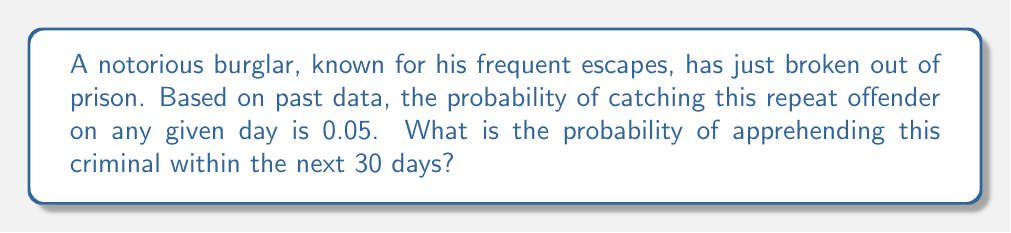Can you answer this question? Let's approach this step-by-step:

1) First, we need to calculate the probability of not catching the burglar on a single day:
   $P(\text{not caught on one day}) = 1 - 0.05 = 0.95$

2) Now, to not catch the burglar within 30 days, we need to not catch him every single day for 30 days. The probability of this is:
   $P(\text{not caught in 30 days}) = 0.95^{30}$

3) We can calculate this:
   $0.95^{30} \approx 0.2147$

4) The probability we're looking for is the opposite of this - the probability of catching the burglar within 30 days. This is:
   $P(\text{caught within 30 days}) = 1 - P(\text{not caught in 30 days})$

5) So, our final calculation is:
   $P(\text{caught within 30 days}) = 1 - 0.2147 = 0.7853$

6) This can be expressed as a percentage:
   $0.7853 \times 100\% = 78.53\%$
Answer: 78.53% 